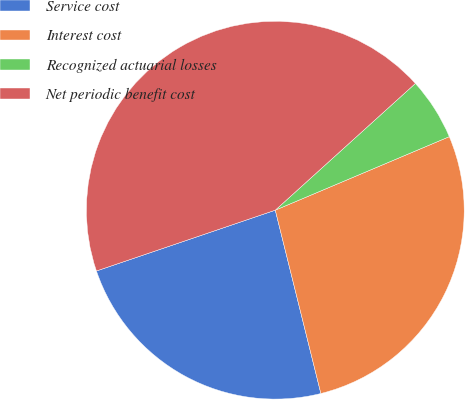Convert chart to OTSL. <chart><loc_0><loc_0><loc_500><loc_500><pie_chart><fcel>Service cost<fcel>Interest cost<fcel>Recognized actuarial losses<fcel>Net periodic benefit cost<nl><fcel>23.66%<fcel>27.48%<fcel>5.34%<fcel>43.51%<nl></chart> 